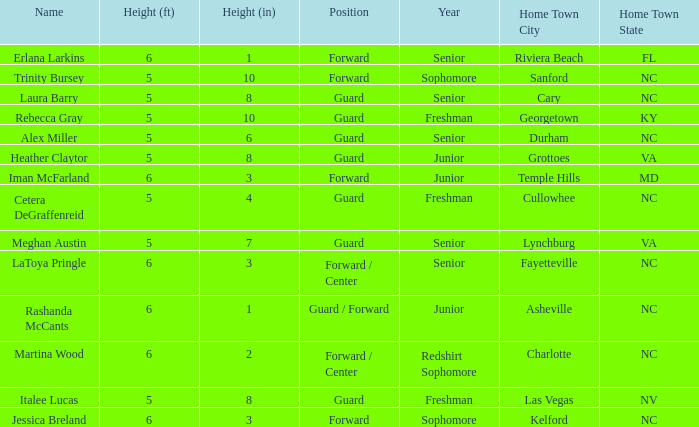In what year of school is the player from Fayetteville, NC? Senior. 